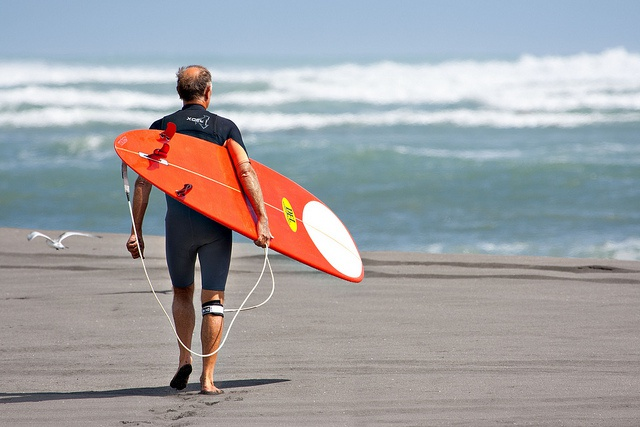Describe the objects in this image and their specific colors. I can see surfboard in darkgray, red, salmon, and white tones, people in darkgray, black, maroon, and salmon tones, and bird in darkgray, lightgray, and gray tones in this image. 